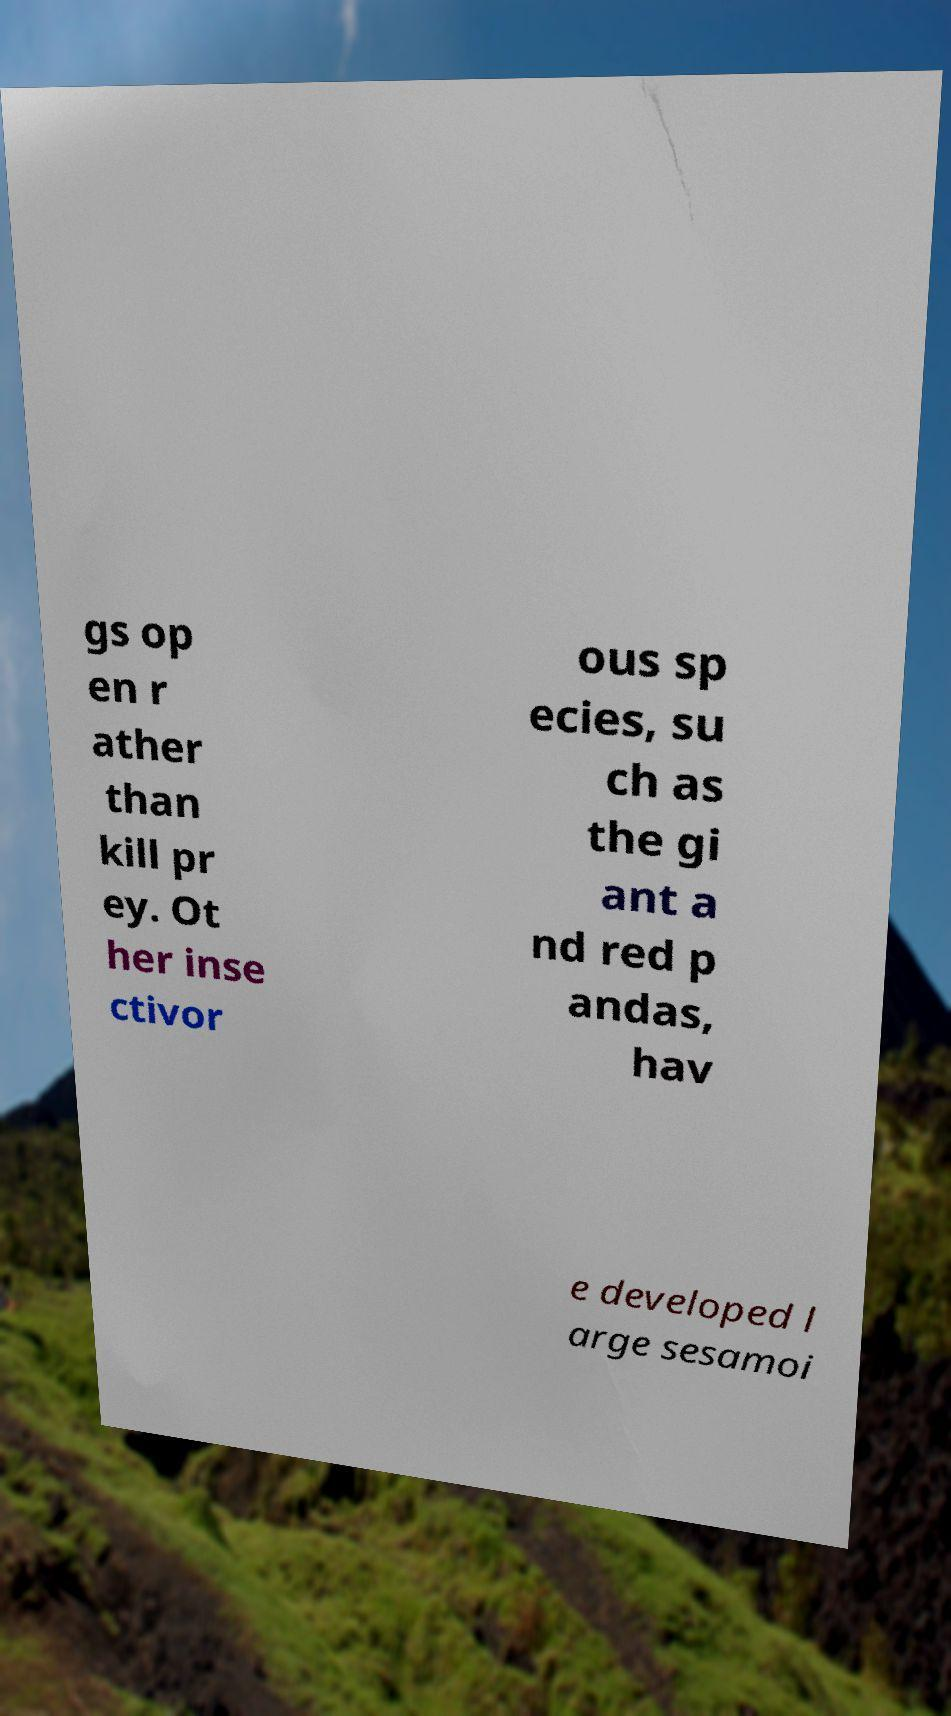Please read and relay the text visible in this image. What does it say? gs op en r ather than kill pr ey. Ot her inse ctivor ous sp ecies, su ch as the gi ant a nd red p andas, hav e developed l arge sesamoi 